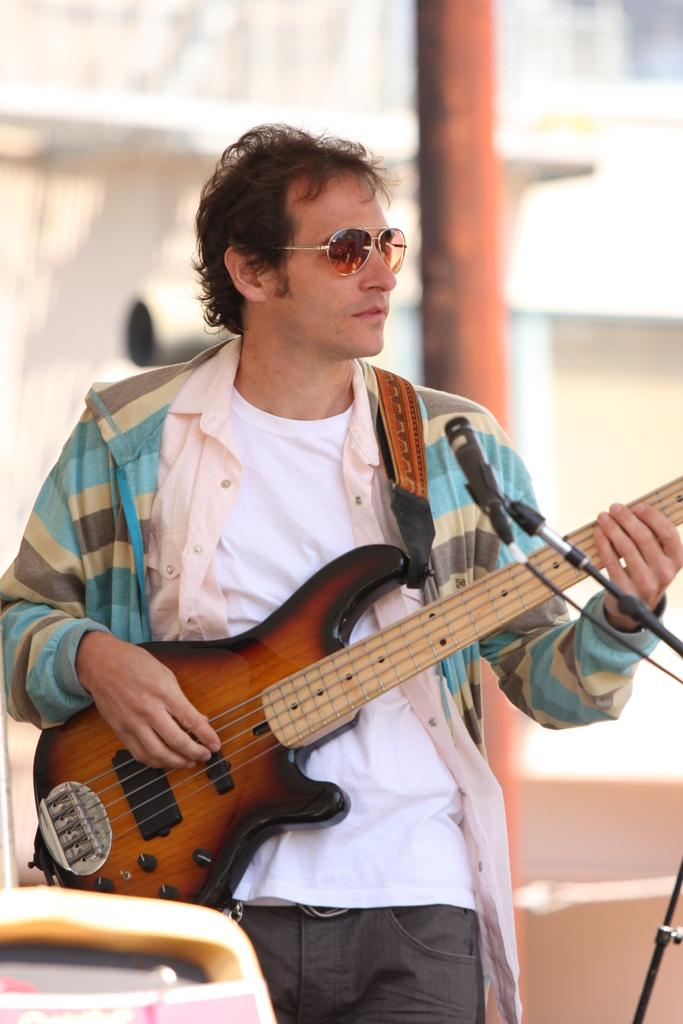What is the main subject of the image? The main subject of the image is a man. What is the man wearing in the image? The man is wearing a jacket and spectacles in the image. What is the man holding in the image? The man is holding a guitar in the image. What is the man doing with the guitar? The man is playing the guitar in the image. What is the man doing with his mouth in the image? The man is singing into a microphone in the image. What can be seen in the background of the image? There is a pillar in the background of the image. How would you describe the background of the image? The background of the image is blurred. What type of building is visible in the background of the image? There is no building visible in the background of the image; only a pillar can be seen. What type of group is the man a part of in the image? The image does not show the man as part of any group; he is performing solo. 